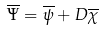<formula> <loc_0><loc_0><loc_500><loc_500>\overline { \Psi } = \overline { \psi } + D \overline { \chi }</formula> 